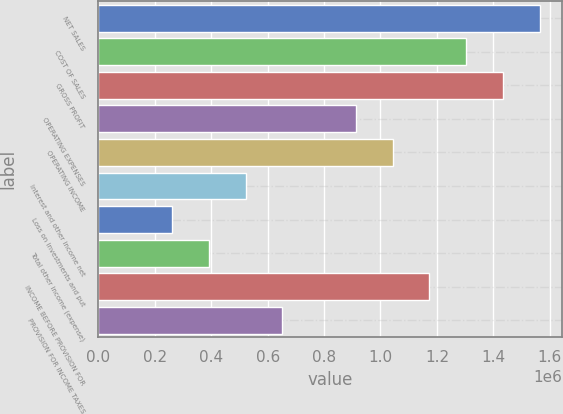<chart> <loc_0><loc_0><loc_500><loc_500><bar_chart><fcel>NET SALES<fcel>COST OF SALES<fcel>GROSS PROFIT<fcel>OPERATING EXPENSES<fcel>OPERATING INCOME<fcel>Interest and other income net<fcel>Loss on investments and put<fcel>Total other income (expense)<fcel>INCOME BEFORE PROVISION FOR<fcel>PROVISION FOR INCOME TAXES<nl><fcel>1.56473e+06<fcel>1.30394e+06<fcel>1.43434e+06<fcel>912760<fcel>1.04315e+06<fcel>521578<fcel>260789<fcel>391183<fcel>1.17355e+06<fcel>651972<nl></chart> 